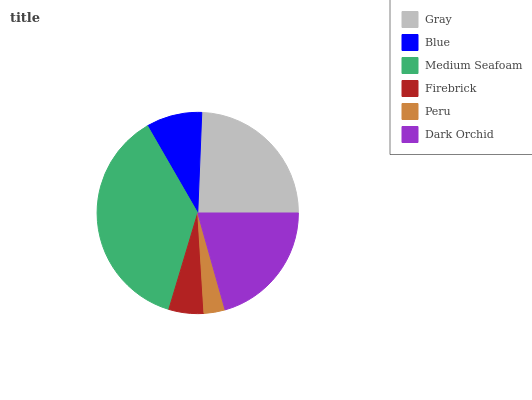Is Peru the minimum?
Answer yes or no. Yes. Is Medium Seafoam the maximum?
Answer yes or no. Yes. Is Blue the minimum?
Answer yes or no. No. Is Blue the maximum?
Answer yes or no. No. Is Gray greater than Blue?
Answer yes or no. Yes. Is Blue less than Gray?
Answer yes or no. Yes. Is Blue greater than Gray?
Answer yes or no. No. Is Gray less than Blue?
Answer yes or no. No. Is Dark Orchid the high median?
Answer yes or no. Yes. Is Blue the low median?
Answer yes or no. Yes. Is Medium Seafoam the high median?
Answer yes or no. No. Is Gray the low median?
Answer yes or no. No. 